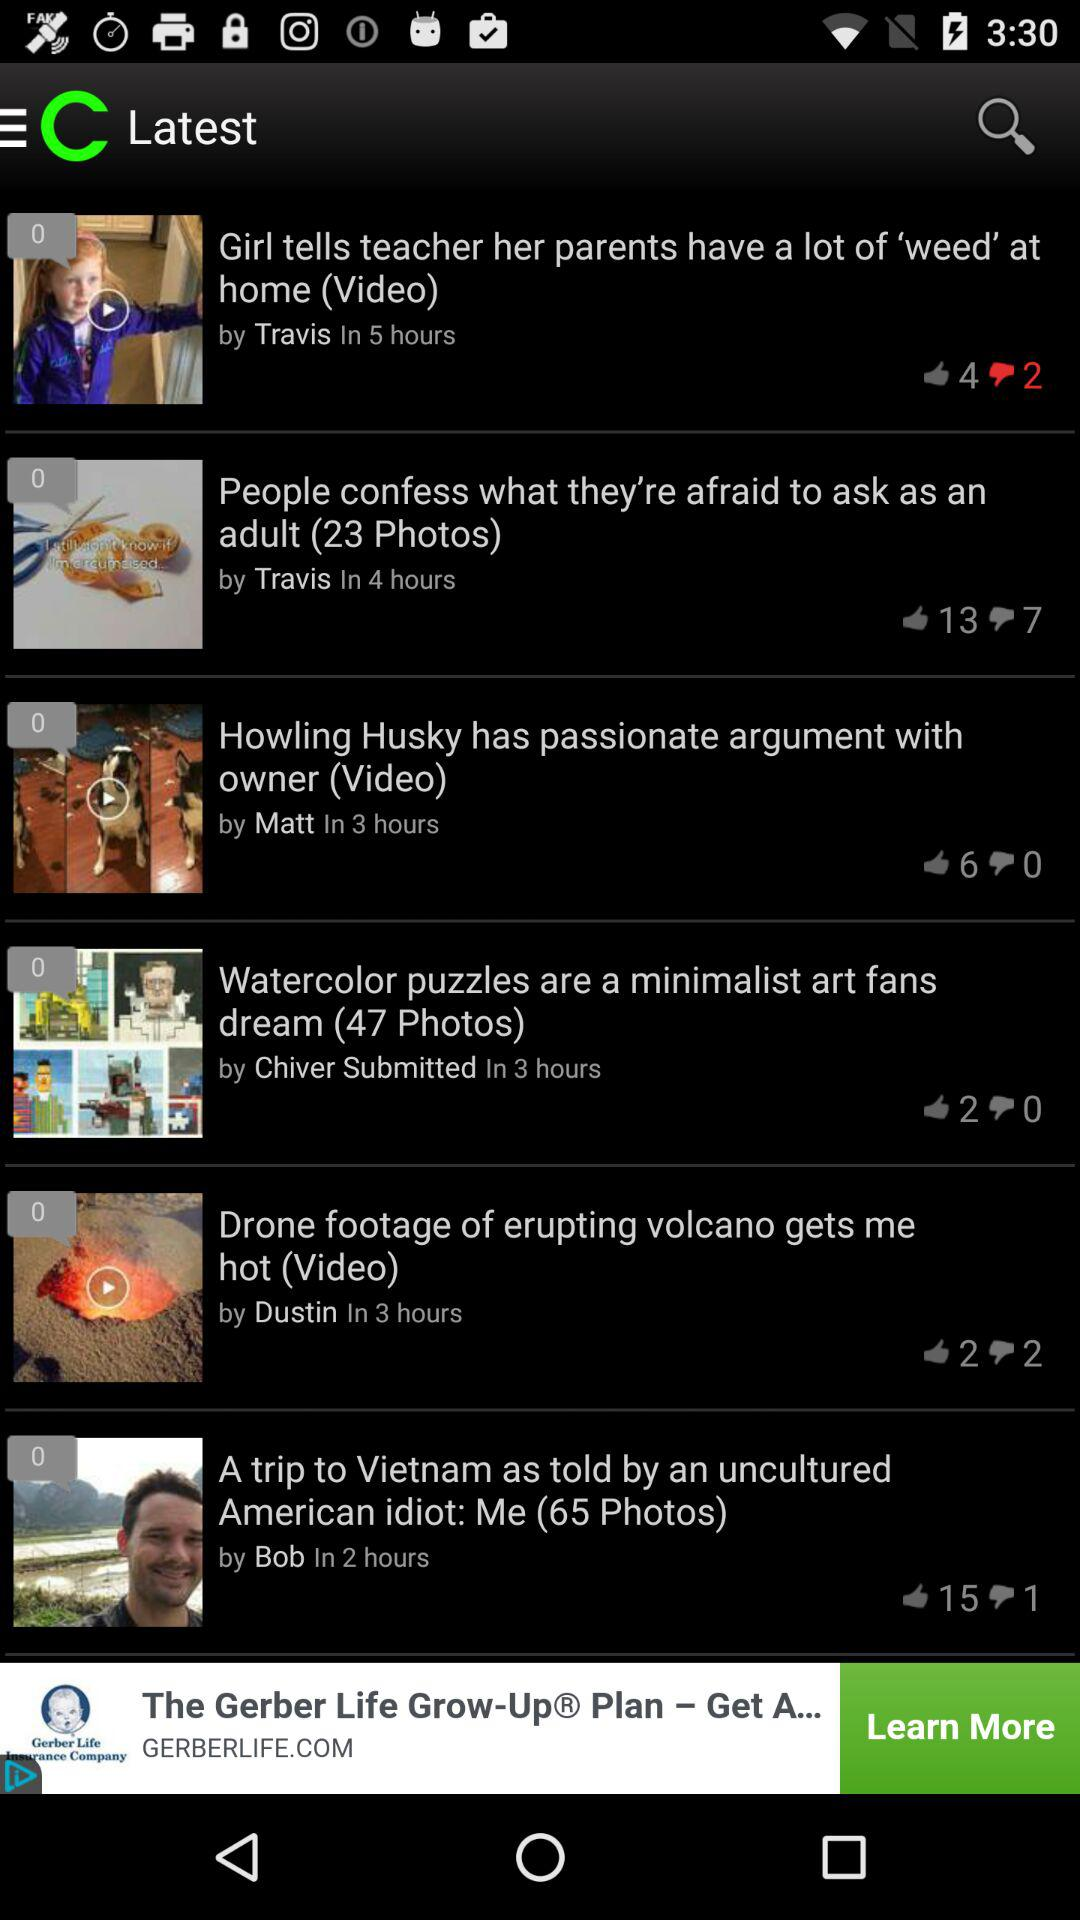How many hours ago was the post "Girl tells teacher her parents have a lot of 'weed' at home" posted? It was posted 5 hours ago. 